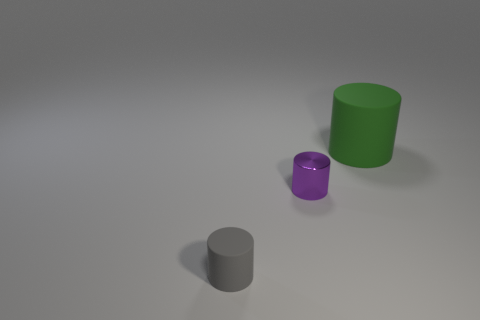Subtract all big green rubber cylinders. How many cylinders are left? 2 Add 2 gray cylinders. How many objects exist? 5 Subtract all tiny gray objects. Subtract all big gray cylinders. How many objects are left? 2 Add 1 big things. How many big things are left? 2 Add 2 big red objects. How many big red objects exist? 2 Subtract 1 gray cylinders. How many objects are left? 2 